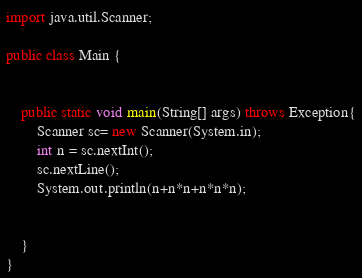<code> <loc_0><loc_0><loc_500><loc_500><_Java_>import java.util.Scanner;

public class Main {
	
	
	public static void main(String[] args) throws Exception{
		Scanner sc= new Scanner(System.in);
		int n = sc.nextInt();
		sc.nextLine();
		System.out.println(n+n*n+n*n*n);
		
		
	}
}
</code> 